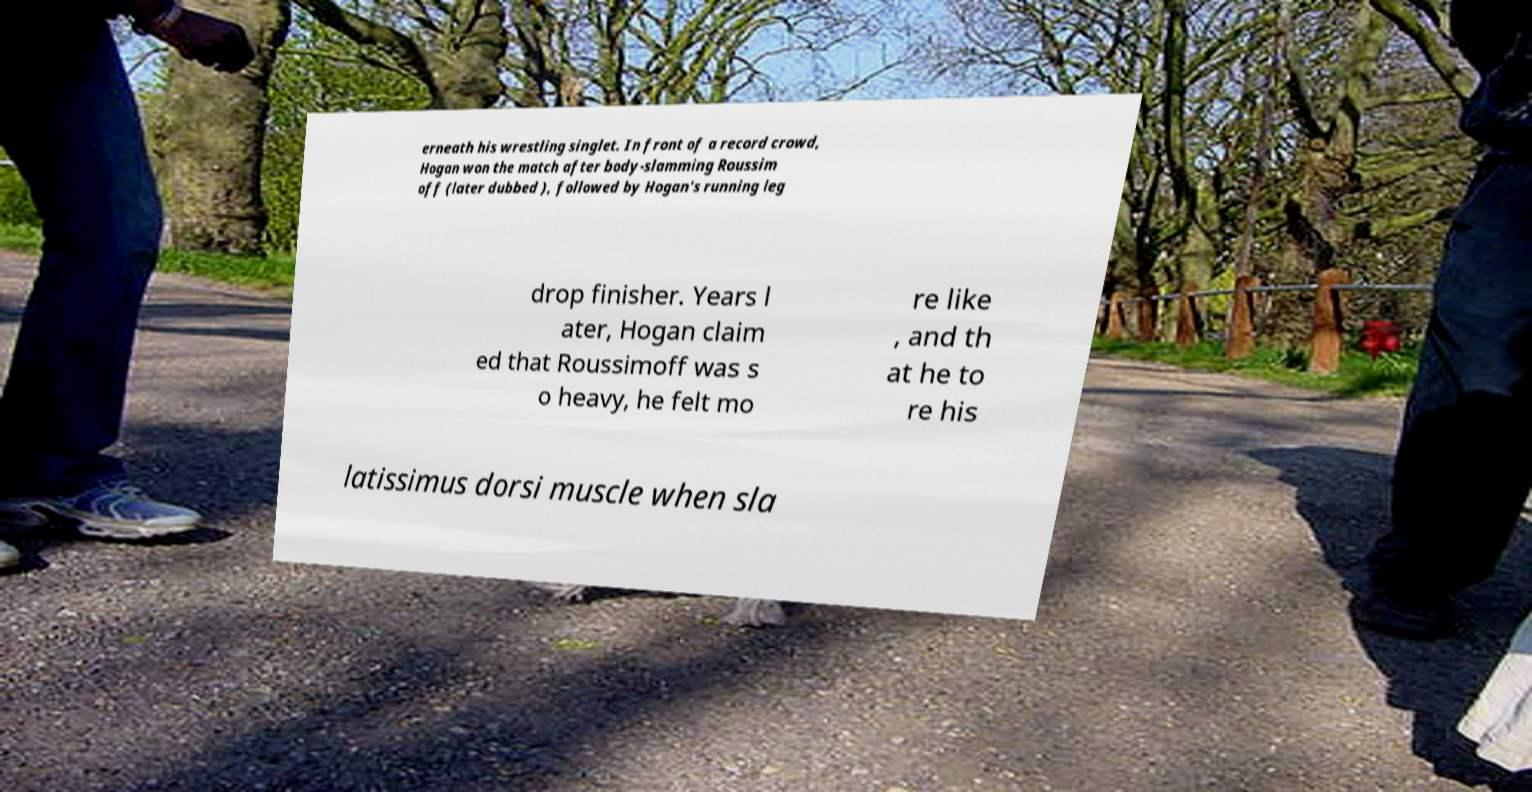There's text embedded in this image that I need extracted. Can you transcribe it verbatim? erneath his wrestling singlet. In front of a record crowd, Hogan won the match after body-slamming Roussim off (later dubbed ), followed by Hogan's running leg drop finisher. Years l ater, Hogan claim ed that Roussimoff was s o heavy, he felt mo re like , and th at he to re his latissimus dorsi muscle when sla 